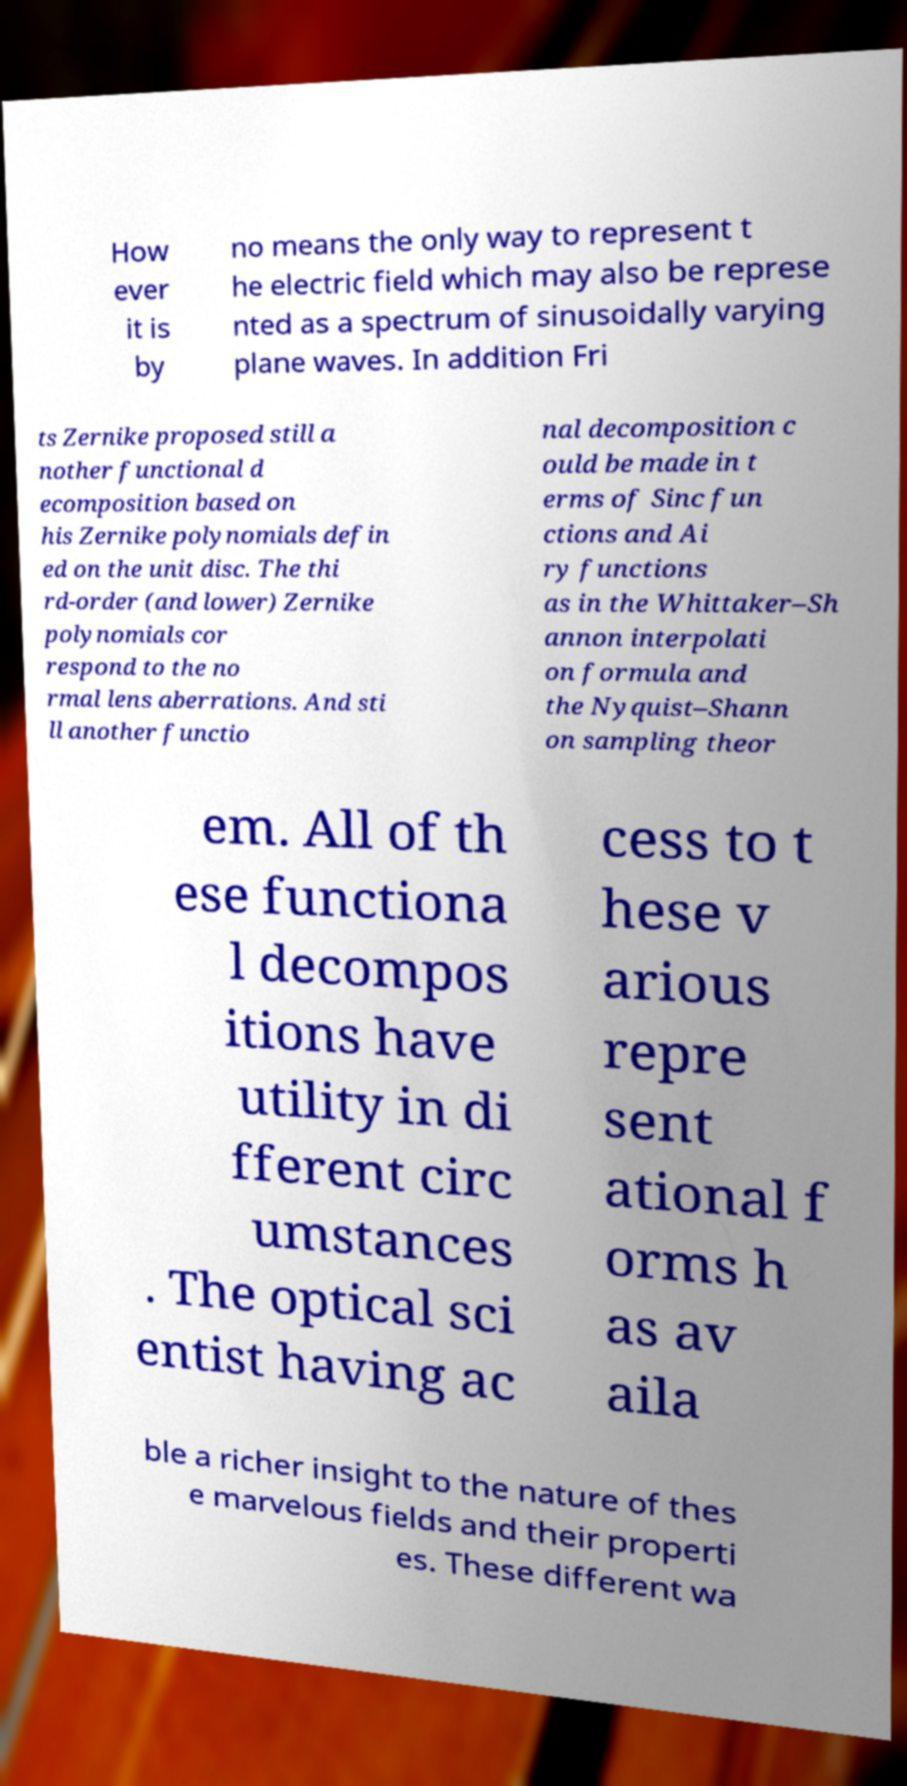For documentation purposes, I need the text within this image transcribed. Could you provide that? How ever it is by no means the only way to represent t he electric field which may also be represe nted as a spectrum of sinusoidally varying plane waves. In addition Fri ts Zernike proposed still a nother functional d ecomposition based on his Zernike polynomials defin ed on the unit disc. The thi rd-order (and lower) Zernike polynomials cor respond to the no rmal lens aberrations. And sti ll another functio nal decomposition c ould be made in t erms of Sinc fun ctions and Ai ry functions as in the Whittaker–Sh annon interpolati on formula and the Nyquist–Shann on sampling theor em. All of th ese functiona l decompos itions have utility in di fferent circ umstances . The optical sci entist having ac cess to t hese v arious repre sent ational f orms h as av aila ble a richer insight to the nature of thes e marvelous fields and their properti es. These different wa 